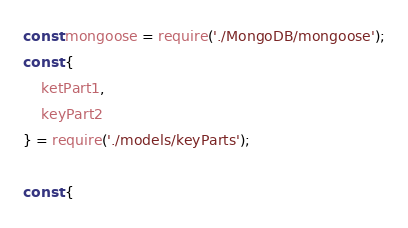<code> <loc_0><loc_0><loc_500><loc_500><_JavaScript_>const mongoose = require('./MongoDB/mongoose');
const {
    ketPart1,
    keyPart2
} = require('./models/keyParts');

const {</code> 